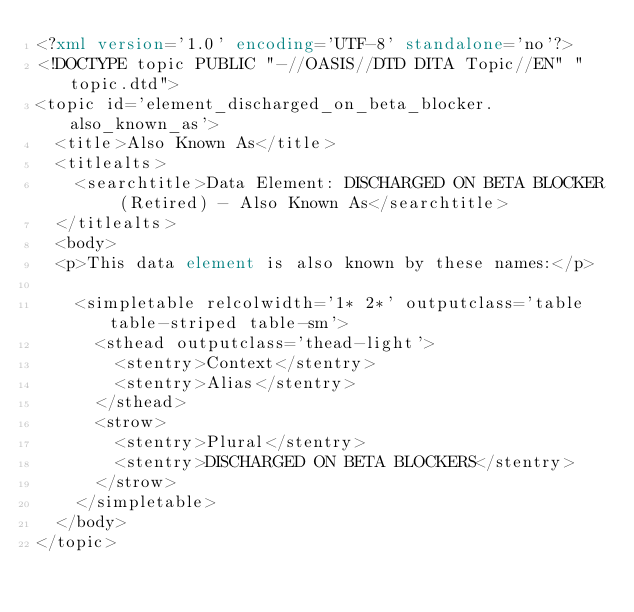Convert code to text. <code><loc_0><loc_0><loc_500><loc_500><_XML_><?xml version='1.0' encoding='UTF-8' standalone='no'?>
<!DOCTYPE topic PUBLIC "-//OASIS//DTD DITA Topic//EN" "topic.dtd">
<topic id='element_discharged_on_beta_blocker.also_known_as'>
  <title>Also Known As</title>
  <titlealts>
    <searchtitle>Data Element: DISCHARGED ON BETA BLOCKER (Retired) - Also Known As</searchtitle>
  </titlealts>
  <body>
  <p>This data element is also known by these names:</p>

    <simpletable relcolwidth='1* 2*' outputclass='table table-striped table-sm'>
      <sthead outputclass='thead-light'>
        <stentry>Context</stentry>
        <stentry>Alias</stentry>
      </sthead>
      <strow>
        <stentry>Plural</stentry>
        <stentry>DISCHARGED ON BETA BLOCKERS</stentry>
      </strow>
    </simpletable>
  </body>
</topic></code> 